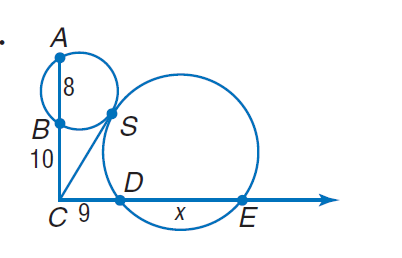Answer the mathemtical geometry problem and directly provide the correct option letter.
Question: Find x. Round to the nearest tenth, if necessary.
Choices: A: 8 B: 9 C: 10 D: 11 D 